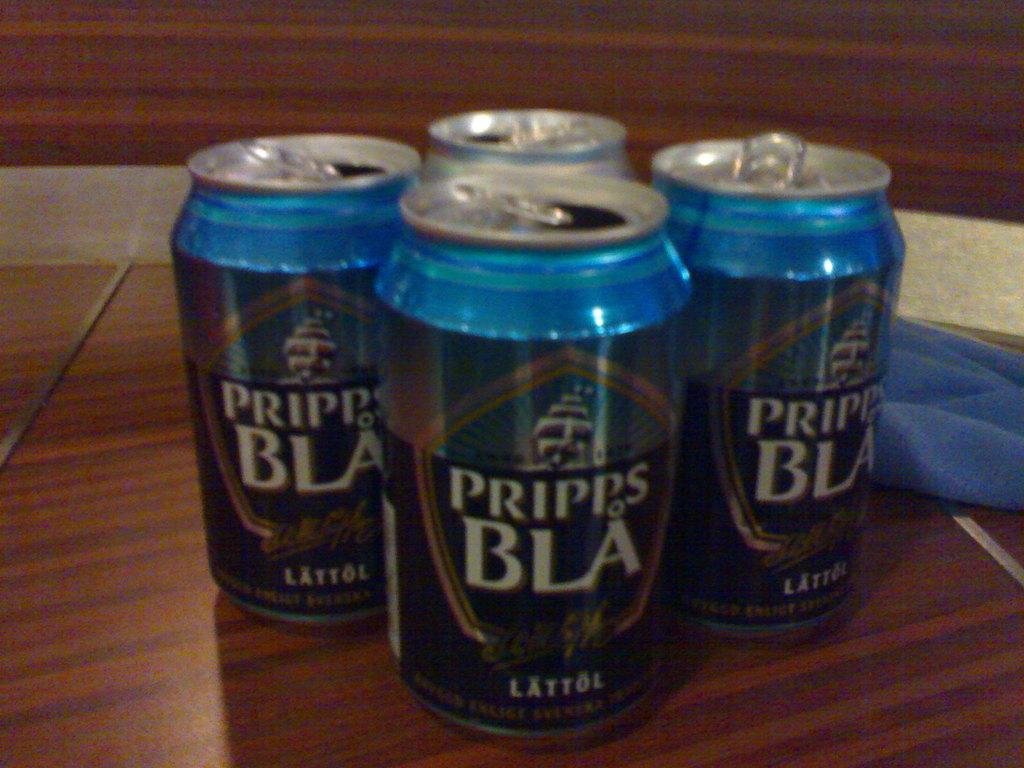<image>
Give a short and clear explanation of the subsequent image. three opened aluminum cans of pripps bla lattol 